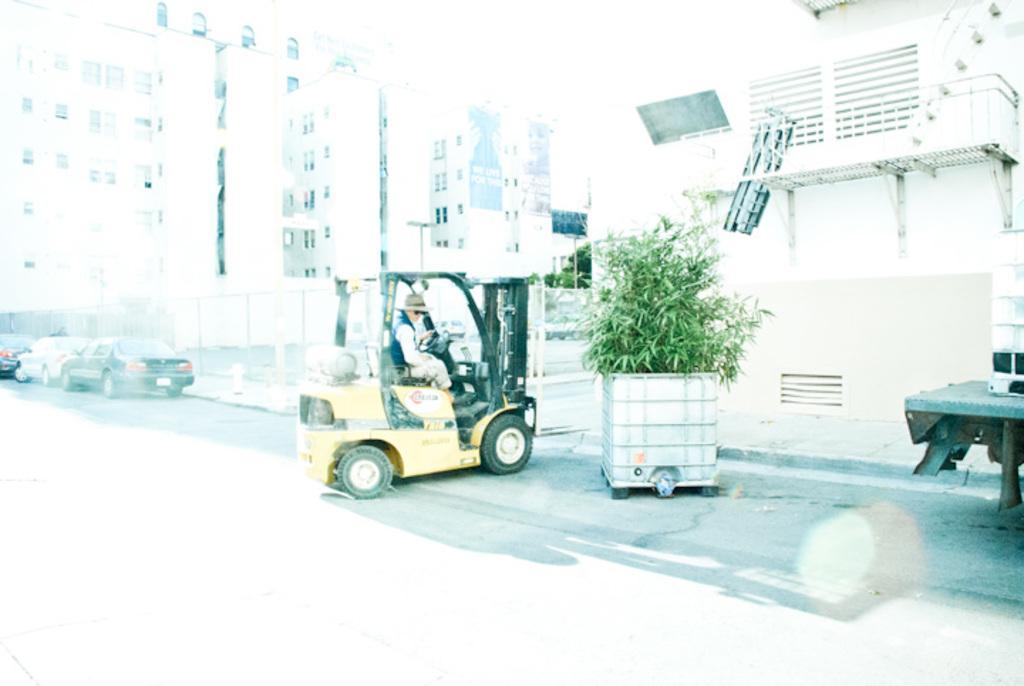Please provide a concise description of this image. In this image there is a person driving a four wheeler and at the background of the image there are buildings and cars. 